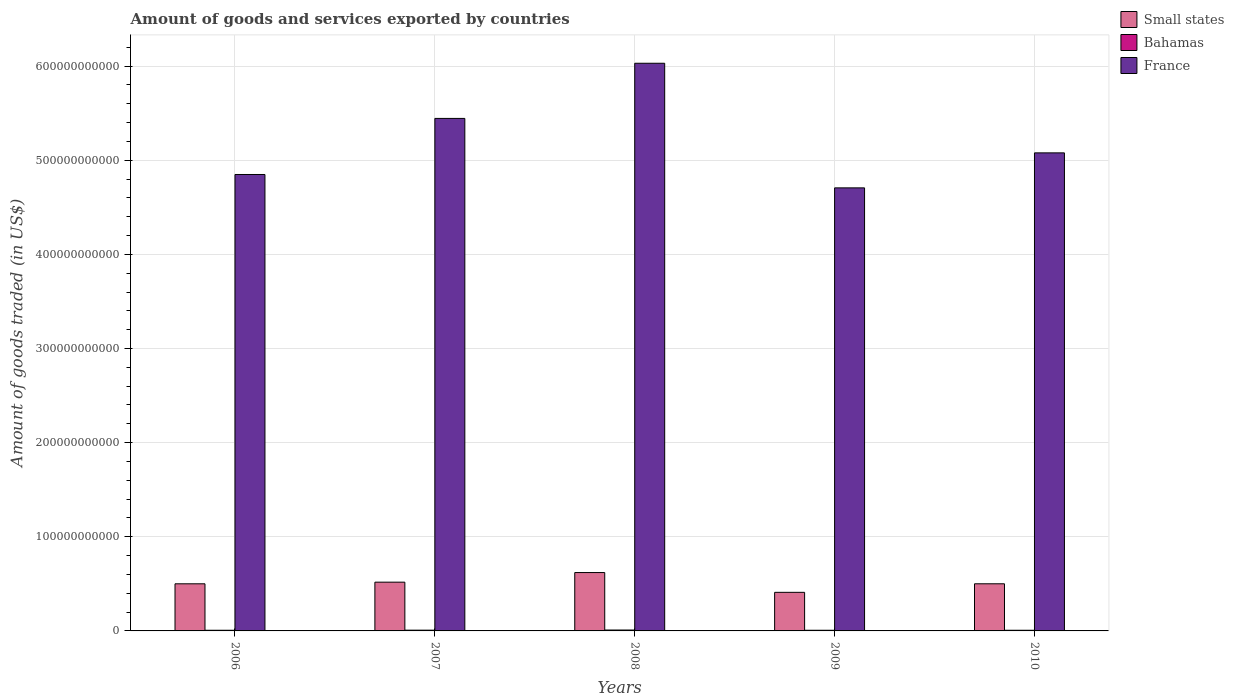Are the number of bars per tick equal to the number of legend labels?
Provide a short and direct response. Yes. Are the number of bars on each tick of the X-axis equal?
Your answer should be compact. Yes. How many bars are there on the 3rd tick from the left?
Your answer should be very brief. 3. How many bars are there on the 4th tick from the right?
Offer a very short reply. 3. What is the total amount of goods and services exported in Bahamas in 2006?
Make the answer very short. 7.04e+08. Across all years, what is the maximum total amount of goods and services exported in France?
Your answer should be compact. 6.03e+11. Across all years, what is the minimum total amount of goods and services exported in Small states?
Ensure brevity in your answer.  4.10e+1. In which year was the total amount of goods and services exported in Small states minimum?
Keep it short and to the point. 2009. What is the total total amount of goods and services exported in Small states in the graph?
Provide a short and direct response. 2.55e+11. What is the difference between the total amount of goods and services exported in France in 2007 and that in 2009?
Your answer should be compact. 7.38e+1. What is the difference between the total amount of goods and services exported in Small states in 2009 and the total amount of goods and services exported in France in 2006?
Make the answer very short. -4.44e+11. What is the average total amount of goods and services exported in France per year?
Give a very brief answer. 5.22e+11. In the year 2010, what is the difference between the total amount of goods and services exported in Small states and total amount of goods and services exported in France?
Offer a terse response. -4.58e+11. What is the ratio of the total amount of goods and services exported in France in 2006 to that in 2007?
Your response must be concise. 0.89. What is the difference between the highest and the second highest total amount of goods and services exported in Small states?
Your answer should be very brief. 1.02e+1. What is the difference between the highest and the lowest total amount of goods and services exported in France?
Make the answer very short. 1.32e+11. In how many years, is the total amount of goods and services exported in France greater than the average total amount of goods and services exported in France taken over all years?
Keep it short and to the point. 2. What does the 2nd bar from the left in 2007 represents?
Make the answer very short. Bahamas. What does the 1st bar from the right in 2006 represents?
Your answer should be very brief. France. How many bars are there?
Give a very brief answer. 15. What is the difference between two consecutive major ticks on the Y-axis?
Your response must be concise. 1.00e+11. Does the graph contain any zero values?
Provide a succinct answer. No. Does the graph contain grids?
Keep it short and to the point. Yes. How are the legend labels stacked?
Offer a terse response. Vertical. What is the title of the graph?
Offer a terse response. Amount of goods and services exported by countries. What is the label or title of the Y-axis?
Offer a very short reply. Amount of goods traded (in US$). What is the Amount of goods traded (in US$) in Small states in 2006?
Offer a very short reply. 5.01e+1. What is the Amount of goods traded (in US$) of Bahamas in 2006?
Your answer should be very brief. 7.04e+08. What is the Amount of goods traded (in US$) of France in 2006?
Make the answer very short. 4.85e+11. What is the Amount of goods traded (in US$) of Small states in 2007?
Offer a very short reply. 5.18e+1. What is the Amount of goods traded (in US$) of Bahamas in 2007?
Your response must be concise. 8.02e+08. What is the Amount of goods traded (in US$) in France in 2007?
Give a very brief answer. 5.44e+11. What is the Amount of goods traded (in US$) of Small states in 2008?
Give a very brief answer. 6.20e+1. What is the Amount of goods traded (in US$) of Bahamas in 2008?
Keep it short and to the point. 9.56e+08. What is the Amount of goods traded (in US$) in France in 2008?
Offer a terse response. 6.03e+11. What is the Amount of goods traded (in US$) in Small states in 2009?
Give a very brief answer. 4.10e+1. What is the Amount of goods traded (in US$) in Bahamas in 2009?
Provide a succinct answer. 7.11e+08. What is the Amount of goods traded (in US$) in France in 2009?
Provide a succinct answer. 4.71e+11. What is the Amount of goods traded (in US$) of Small states in 2010?
Your answer should be compact. 5.01e+1. What is the Amount of goods traded (in US$) in Bahamas in 2010?
Offer a terse response. 7.02e+08. What is the Amount of goods traded (in US$) of France in 2010?
Make the answer very short. 5.08e+11. Across all years, what is the maximum Amount of goods traded (in US$) of Small states?
Your response must be concise. 6.20e+1. Across all years, what is the maximum Amount of goods traded (in US$) of Bahamas?
Give a very brief answer. 9.56e+08. Across all years, what is the maximum Amount of goods traded (in US$) in France?
Offer a very short reply. 6.03e+11. Across all years, what is the minimum Amount of goods traded (in US$) in Small states?
Your answer should be very brief. 4.10e+1. Across all years, what is the minimum Amount of goods traded (in US$) of Bahamas?
Keep it short and to the point. 7.02e+08. Across all years, what is the minimum Amount of goods traded (in US$) of France?
Give a very brief answer. 4.71e+11. What is the total Amount of goods traded (in US$) in Small states in the graph?
Give a very brief answer. 2.55e+11. What is the total Amount of goods traded (in US$) in Bahamas in the graph?
Give a very brief answer. 3.87e+09. What is the total Amount of goods traded (in US$) of France in the graph?
Your answer should be very brief. 2.61e+12. What is the difference between the Amount of goods traded (in US$) of Small states in 2006 and that in 2007?
Make the answer very short. -1.74e+09. What is the difference between the Amount of goods traded (in US$) of Bahamas in 2006 and that in 2007?
Your answer should be compact. -9.83e+07. What is the difference between the Amount of goods traded (in US$) in France in 2006 and that in 2007?
Keep it short and to the point. -5.96e+1. What is the difference between the Amount of goods traded (in US$) in Small states in 2006 and that in 2008?
Give a very brief answer. -1.19e+1. What is the difference between the Amount of goods traded (in US$) of Bahamas in 2006 and that in 2008?
Offer a terse response. -2.52e+08. What is the difference between the Amount of goods traded (in US$) of France in 2006 and that in 2008?
Provide a short and direct response. -1.18e+11. What is the difference between the Amount of goods traded (in US$) in Small states in 2006 and that in 2009?
Your response must be concise. 9.06e+09. What is the difference between the Amount of goods traded (in US$) in Bahamas in 2006 and that in 2009?
Provide a short and direct response. -7.14e+06. What is the difference between the Amount of goods traded (in US$) in France in 2006 and that in 2009?
Offer a very short reply. 1.42e+1. What is the difference between the Amount of goods traded (in US$) of Small states in 2006 and that in 2010?
Give a very brief answer. -1.86e+07. What is the difference between the Amount of goods traded (in US$) of Bahamas in 2006 and that in 2010?
Your answer should be compact. 1.10e+06. What is the difference between the Amount of goods traded (in US$) in France in 2006 and that in 2010?
Provide a succinct answer. -2.30e+1. What is the difference between the Amount of goods traded (in US$) of Small states in 2007 and that in 2008?
Offer a terse response. -1.02e+1. What is the difference between the Amount of goods traded (in US$) of Bahamas in 2007 and that in 2008?
Make the answer very short. -1.54e+08. What is the difference between the Amount of goods traded (in US$) of France in 2007 and that in 2008?
Provide a short and direct response. -5.86e+1. What is the difference between the Amount of goods traded (in US$) of Small states in 2007 and that in 2009?
Your response must be concise. 1.08e+1. What is the difference between the Amount of goods traded (in US$) of Bahamas in 2007 and that in 2009?
Provide a short and direct response. 9.12e+07. What is the difference between the Amount of goods traded (in US$) of France in 2007 and that in 2009?
Your answer should be very brief. 7.38e+1. What is the difference between the Amount of goods traded (in US$) of Small states in 2007 and that in 2010?
Your answer should be very brief. 1.73e+09. What is the difference between the Amount of goods traded (in US$) of Bahamas in 2007 and that in 2010?
Provide a short and direct response. 9.94e+07. What is the difference between the Amount of goods traded (in US$) of France in 2007 and that in 2010?
Your answer should be compact. 3.66e+1. What is the difference between the Amount of goods traded (in US$) of Small states in 2008 and that in 2009?
Offer a very short reply. 2.10e+1. What is the difference between the Amount of goods traded (in US$) in Bahamas in 2008 and that in 2009?
Ensure brevity in your answer.  2.45e+08. What is the difference between the Amount of goods traded (in US$) in France in 2008 and that in 2009?
Your response must be concise. 1.32e+11. What is the difference between the Amount of goods traded (in US$) in Small states in 2008 and that in 2010?
Ensure brevity in your answer.  1.19e+1. What is the difference between the Amount of goods traded (in US$) of Bahamas in 2008 and that in 2010?
Provide a short and direct response. 2.53e+08. What is the difference between the Amount of goods traded (in US$) in France in 2008 and that in 2010?
Offer a very short reply. 9.52e+1. What is the difference between the Amount of goods traded (in US$) in Small states in 2009 and that in 2010?
Keep it short and to the point. -9.08e+09. What is the difference between the Amount of goods traded (in US$) in Bahamas in 2009 and that in 2010?
Your answer should be compact. 8.24e+06. What is the difference between the Amount of goods traded (in US$) of France in 2009 and that in 2010?
Ensure brevity in your answer.  -3.72e+1. What is the difference between the Amount of goods traded (in US$) in Small states in 2006 and the Amount of goods traded (in US$) in Bahamas in 2007?
Make the answer very short. 4.93e+1. What is the difference between the Amount of goods traded (in US$) in Small states in 2006 and the Amount of goods traded (in US$) in France in 2007?
Offer a very short reply. -4.94e+11. What is the difference between the Amount of goods traded (in US$) of Bahamas in 2006 and the Amount of goods traded (in US$) of France in 2007?
Your answer should be very brief. -5.44e+11. What is the difference between the Amount of goods traded (in US$) in Small states in 2006 and the Amount of goods traded (in US$) in Bahamas in 2008?
Keep it short and to the point. 4.91e+1. What is the difference between the Amount of goods traded (in US$) of Small states in 2006 and the Amount of goods traded (in US$) of France in 2008?
Give a very brief answer. -5.53e+11. What is the difference between the Amount of goods traded (in US$) in Bahamas in 2006 and the Amount of goods traded (in US$) in France in 2008?
Your response must be concise. -6.02e+11. What is the difference between the Amount of goods traded (in US$) of Small states in 2006 and the Amount of goods traded (in US$) of Bahamas in 2009?
Keep it short and to the point. 4.93e+1. What is the difference between the Amount of goods traded (in US$) in Small states in 2006 and the Amount of goods traded (in US$) in France in 2009?
Your response must be concise. -4.21e+11. What is the difference between the Amount of goods traded (in US$) of Bahamas in 2006 and the Amount of goods traded (in US$) of France in 2009?
Your response must be concise. -4.70e+11. What is the difference between the Amount of goods traded (in US$) in Small states in 2006 and the Amount of goods traded (in US$) in Bahamas in 2010?
Your answer should be very brief. 4.94e+1. What is the difference between the Amount of goods traded (in US$) in Small states in 2006 and the Amount of goods traded (in US$) in France in 2010?
Offer a terse response. -4.58e+11. What is the difference between the Amount of goods traded (in US$) of Bahamas in 2006 and the Amount of goods traded (in US$) of France in 2010?
Keep it short and to the point. -5.07e+11. What is the difference between the Amount of goods traded (in US$) in Small states in 2007 and the Amount of goods traded (in US$) in Bahamas in 2008?
Your answer should be very brief. 5.08e+1. What is the difference between the Amount of goods traded (in US$) in Small states in 2007 and the Amount of goods traded (in US$) in France in 2008?
Your answer should be very brief. -5.51e+11. What is the difference between the Amount of goods traded (in US$) of Bahamas in 2007 and the Amount of goods traded (in US$) of France in 2008?
Your answer should be very brief. -6.02e+11. What is the difference between the Amount of goods traded (in US$) in Small states in 2007 and the Amount of goods traded (in US$) in Bahamas in 2009?
Your answer should be very brief. 5.11e+1. What is the difference between the Amount of goods traded (in US$) in Small states in 2007 and the Amount of goods traded (in US$) in France in 2009?
Offer a very short reply. -4.19e+11. What is the difference between the Amount of goods traded (in US$) of Bahamas in 2007 and the Amount of goods traded (in US$) of France in 2009?
Provide a succinct answer. -4.70e+11. What is the difference between the Amount of goods traded (in US$) of Small states in 2007 and the Amount of goods traded (in US$) of Bahamas in 2010?
Offer a very short reply. 5.11e+1. What is the difference between the Amount of goods traded (in US$) in Small states in 2007 and the Amount of goods traded (in US$) in France in 2010?
Provide a short and direct response. -4.56e+11. What is the difference between the Amount of goods traded (in US$) of Bahamas in 2007 and the Amount of goods traded (in US$) of France in 2010?
Your answer should be very brief. -5.07e+11. What is the difference between the Amount of goods traded (in US$) of Small states in 2008 and the Amount of goods traded (in US$) of Bahamas in 2009?
Offer a very short reply. 6.13e+1. What is the difference between the Amount of goods traded (in US$) of Small states in 2008 and the Amount of goods traded (in US$) of France in 2009?
Provide a short and direct response. -4.09e+11. What is the difference between the Amount of goods traded (in US$) in Bahamas in 2008 and the Amount of goods traded (in US$) in France in 2009?
Ensure brevity in your answer.  -4.70e+11. What is the difference between the Amount of goods traded (in US$) of Small states in 2008 and the Amount of goods traded (in US$) of Bahamas in 2010?
Give a very brief answer. 6.13e+1. What is the difference between the Amount of goods traded (in US$) in Small states in 2008 and the Amount of goods traded (in US$) in France in 2010?
Offer a very short reply. -4.46e+11. What is the difference between the Amount of goods traded (in US$) of Bahamas in 2008 and the Amount of goods traded (in US$) of France in 2010?
Your response must be concise. -5.07e+11. What is the difference between the Amount of goods traded (in US$) of Small states in 2009 and the Amount of goods traded (in US$) of Bahamas in 2010?
Your answer should be very brief. 4.03e+1. What is the difference between the Amount of goods traded (in US$) in Small states in 2009 and the Amount of goods traded (in US$) in France in 2010?
Your answer should be very brief. -4.67e+11. What is the difference between the Amount of goods traded (in US$) of Bahamas in 2009 and the Amount of goods traded (in US$) of France in 2010?
Your answer should be very brief. -5.07e+11. What is the average Amount of goods traded (in US$) in Small states per year?
Provide a short and direct response. 5.10e+1. What is the average Amount of goods traded (in US$) of Bahamas per year?
Ensure brevity in your answer.  7.75e+08. What is the average Amount of goods traded (in US$) of France per year?
Provide a short and direct response. 5.22e+11. In the year 2006, what is the difference between the Amount of goods traded (in US$) of Small states and Amount of goods traded (in US$) of Bahamas?
Offer a terse response. 4.94e+1. In the year 2006, what is the difference between the Amount of goods traded (in US$) in Small states and Amount of goods traded (in US$) in France?
Provide a short and direct response. -4.35e+11. In the year 2006, what is the difference between the Amount of goods traded (in US$) of Bahamas and Amount of goods traded (in US$) of France?
Keep it short and to the point. -4.84e+11. In the year 2007, what is the difference between the Amount of goods traded (in US$) in Small states and Amount of goods traded (in US$) in Bahamas?
Make the answer very short. 5.10e+1. In the year 2007, what is the difference between the Amount of goods traded (in US$) of Small states and Amount of goods traded (in US$) of France?
Offer a terse response. -4.93e+11. In the year 2007, what is the difference between the Amount of goods traded (in US$) of Bahamas and Amount of goods traded (in US$) of France?
Give a very brief answer. -5.44e+11. In the year 2008, what is the difference between the Amount of goods traded (in US$) of Small states and Amount of goods traded (in US$) of Bahamas?
Your answer should be very brief. 6.10e+1. In the year 2008, what is the difference between the Amount of goods traded (in US$) of Small states and Amount of goods traded (in US$) of France?
Offer a very short reply. -5.41e+11. In the year 2008, what is the difference between the Amount of goods traded (in US$) of Bahamas and Amount of goods traded (in US$) of France?
Your response must be concise. -6.02e+11. In the year 2009, what is the difference between the Amount of goods traded (in US$) in Small states and Amount of goods traded (in US$) in Bahamas?
Your answer should be compact. 4.03e+1. In the year 2009, what is the difference between the Amount of goods traded (in US$) of Small states and Amount of goods traded (in US$) of France?
Ensure brevity in your answer.  -4.30e+11. In the year 2009, what is the difference between the Amount of goods traded (in US$) of Bahamas and Amount of goods traded (in US$) of France?
Keep it short and to the point. -4.70e+11. In the year 2010, what is the difference between the Amount of goods traded (in US$) in Small states and Amount of goods traded (in US$) in Bahamas?
Provide a succinct answer. 4.94e+1. In the year 2010, what is the difference between the Amount of goods traded (in US$) of Small states and Amount of goods traded (in US$) of France?
Make the answer very short. -4.58e+11. In the year 2010, what is the difference between the Amount of goods traded (in US$) of Bahamas and Amount of goods traded (in US$) of France?
Provide a succinct answer. -5.07e+11. What is the ratio of the Amount of goods traded (in US$) of Small states in 2006 to that in 2007?
Keep it short and to the point. 0.97. What is the ratio of the Amount of goods traded (in US$) of Bahamas in 2006 to that in 2007?
Offer a very short reply. 0.88. What is the ratio of the Amount of goods traded (in US$) in France in 2006 to that in 2007?
Your answer should be very brief. 0.89. What is the ratio of the Amount of goods traded (in US$) in Small states in 2006 to that in 2008?
Provide a succinct answer. 0.81. What is the ratio of the Amount of goods traded (in US$) of Bahamas in 2006 to that in 2008?
Your answer should be very brief. 0.74. What is the ratio of the Amount of goods traded (in US$) in France in 2006 to that in 2008?
Offer a very short reply. 0.8. What is the ratio of the Amount of goods traded (in US$) in Small states in 2006 to that in 2009?
Your response must be concise. 1.22. What is the ratio of the Amount of goods traded (in US$) of Bahamas in 2006 to that in 2009?
Your answer should be very brief. 0.99. What is the ratio of the Amount of goods traded (in US$) of France in 2006 to that in 2009?
Provide a short and direct response. 1.03. What is the ratio of the Amount of goods traded (in US$) of Bahamas in 2006 to that in 2010?
Provide a short and direct response. 1. What is the ratio of the Amount of goods traded (in US$) in France in 2006 to that in 2010?
Provide a succinct answer. 0.95. What is the ratio of the Amount of goods traded (in US$) of Small states in 2007 to that in 2008?
Offer a terse response. 0.84. What is the ratio of the Amount of goods traded (in US$) of Bahamas in 2007 to that in 2008?
Offer a terse response. 0.84. What is the ratio of the Amount of goods traded (in US$) of France in 2007 to that in 2008?
Your answer should be compact. 0.9. What is the ratio of the Amount of goods traded (in US$) in Small states in 2007 to that in 2009?
Make the answer very short. 1.26. What is the ratio of the Amount of goods traded (in US$) in Bahamas in 2007 to that in 2009?
Your answer should be compact. 1.13. What is the ratio of the Amount of goods traded (in US$) in France in 2007 to that in 2009?
Give a very brief answer. 1.16. What is the ratio of the Amount of goods traded (in US$) in Small states in 2007 to that in 2010?
Ensure brevity in your answer.  1.03. What is the ratio of the Amount of goods traded (in US$) of Bahamas in 2007 to that in 2010?
Provide a succinct answer. 1.14. What is the ratio of the Amount of goods traded (in US$) of France in 2007 to that in 2010?
Keep it short and to the point. 1.07. What is the ratio of the Amount of goods traded (in US$) in Small states in 2008 to that in 2009?
Make the answer very short. 1.51. What is the ratio of the Amount of goods traded (in US$) in Bahamas in 2008 to that in 2009?
Offer a very short reply. 1.34. What is the ratio of the Amount of goods traded (in US$) in France in 2008 to that in 2009?
Your answer should be very brief. 1.28. What is the ratio of the Amount of goods traded (in US$) in Small states in 2008 to that in 2010?
Offer a terse response. 1.24. What is the ratio of the Amount of goods traded (in US$) in Bahamas in 2008 to that in 2010?
Give a very brief answer. 1.36. What is the ratio of the Amount of goods traded (in US$) in France in 2008 to that in 2010?
Make the answer very short. 1.19. What is the ratio of the Amount of goods traded (in US$) in Small states in 2009 to that in 2010?
Offer a terse response. 0.82. What is the ratio of the Amount of goods traded (in US$) in Bahamas in 2009 to that in 2010?
Keep it short and to the point. 1.01. What is the ratio of the Amount of goods traded (in US$) of France in 2009 to that in 2010?
Make the answer very short. 0.93. What is the difference between the highest and the second highest Amount of goods traded (in US$) in Small states?
Your answer should be very brief. 1.02e+1. What is the difference between the highest and the second highest Amount of goods traded (in US$) in Bahamas?
Your answer should be very brief. 1.54e+08. What is the difference between the highest and the second highest Amount of goods traded (in US$) in France?
Your answer should be very brief. 5.86e+1. What is the difference between the highest and the lowest Amount of goods traded (in US$) in Small states?
Offer a very short reply. 2.10e+1. What is the difference between the highest and the lowest Amount of goods traded (in US$) of Bahamas?
Your answer should be very brief. 2.53e+08. What is the difference between the highest and the lowest Amount of goods traded (in US$) of France?
Your answer should be very brief. 1.32e+11. 